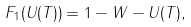Convert formula to latex. <formula><loc_0><loc_0><loc_500><loc_500>F _ { 1 } ( U ( T ) ) = 1 - \| W - U ( T ) \| ,</formula> 